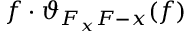<formula> <loc_0><loc_0><loc_500><loc_500>f \cdot \vartheta _ { F _ { x } F - x } ( f )</formula> 